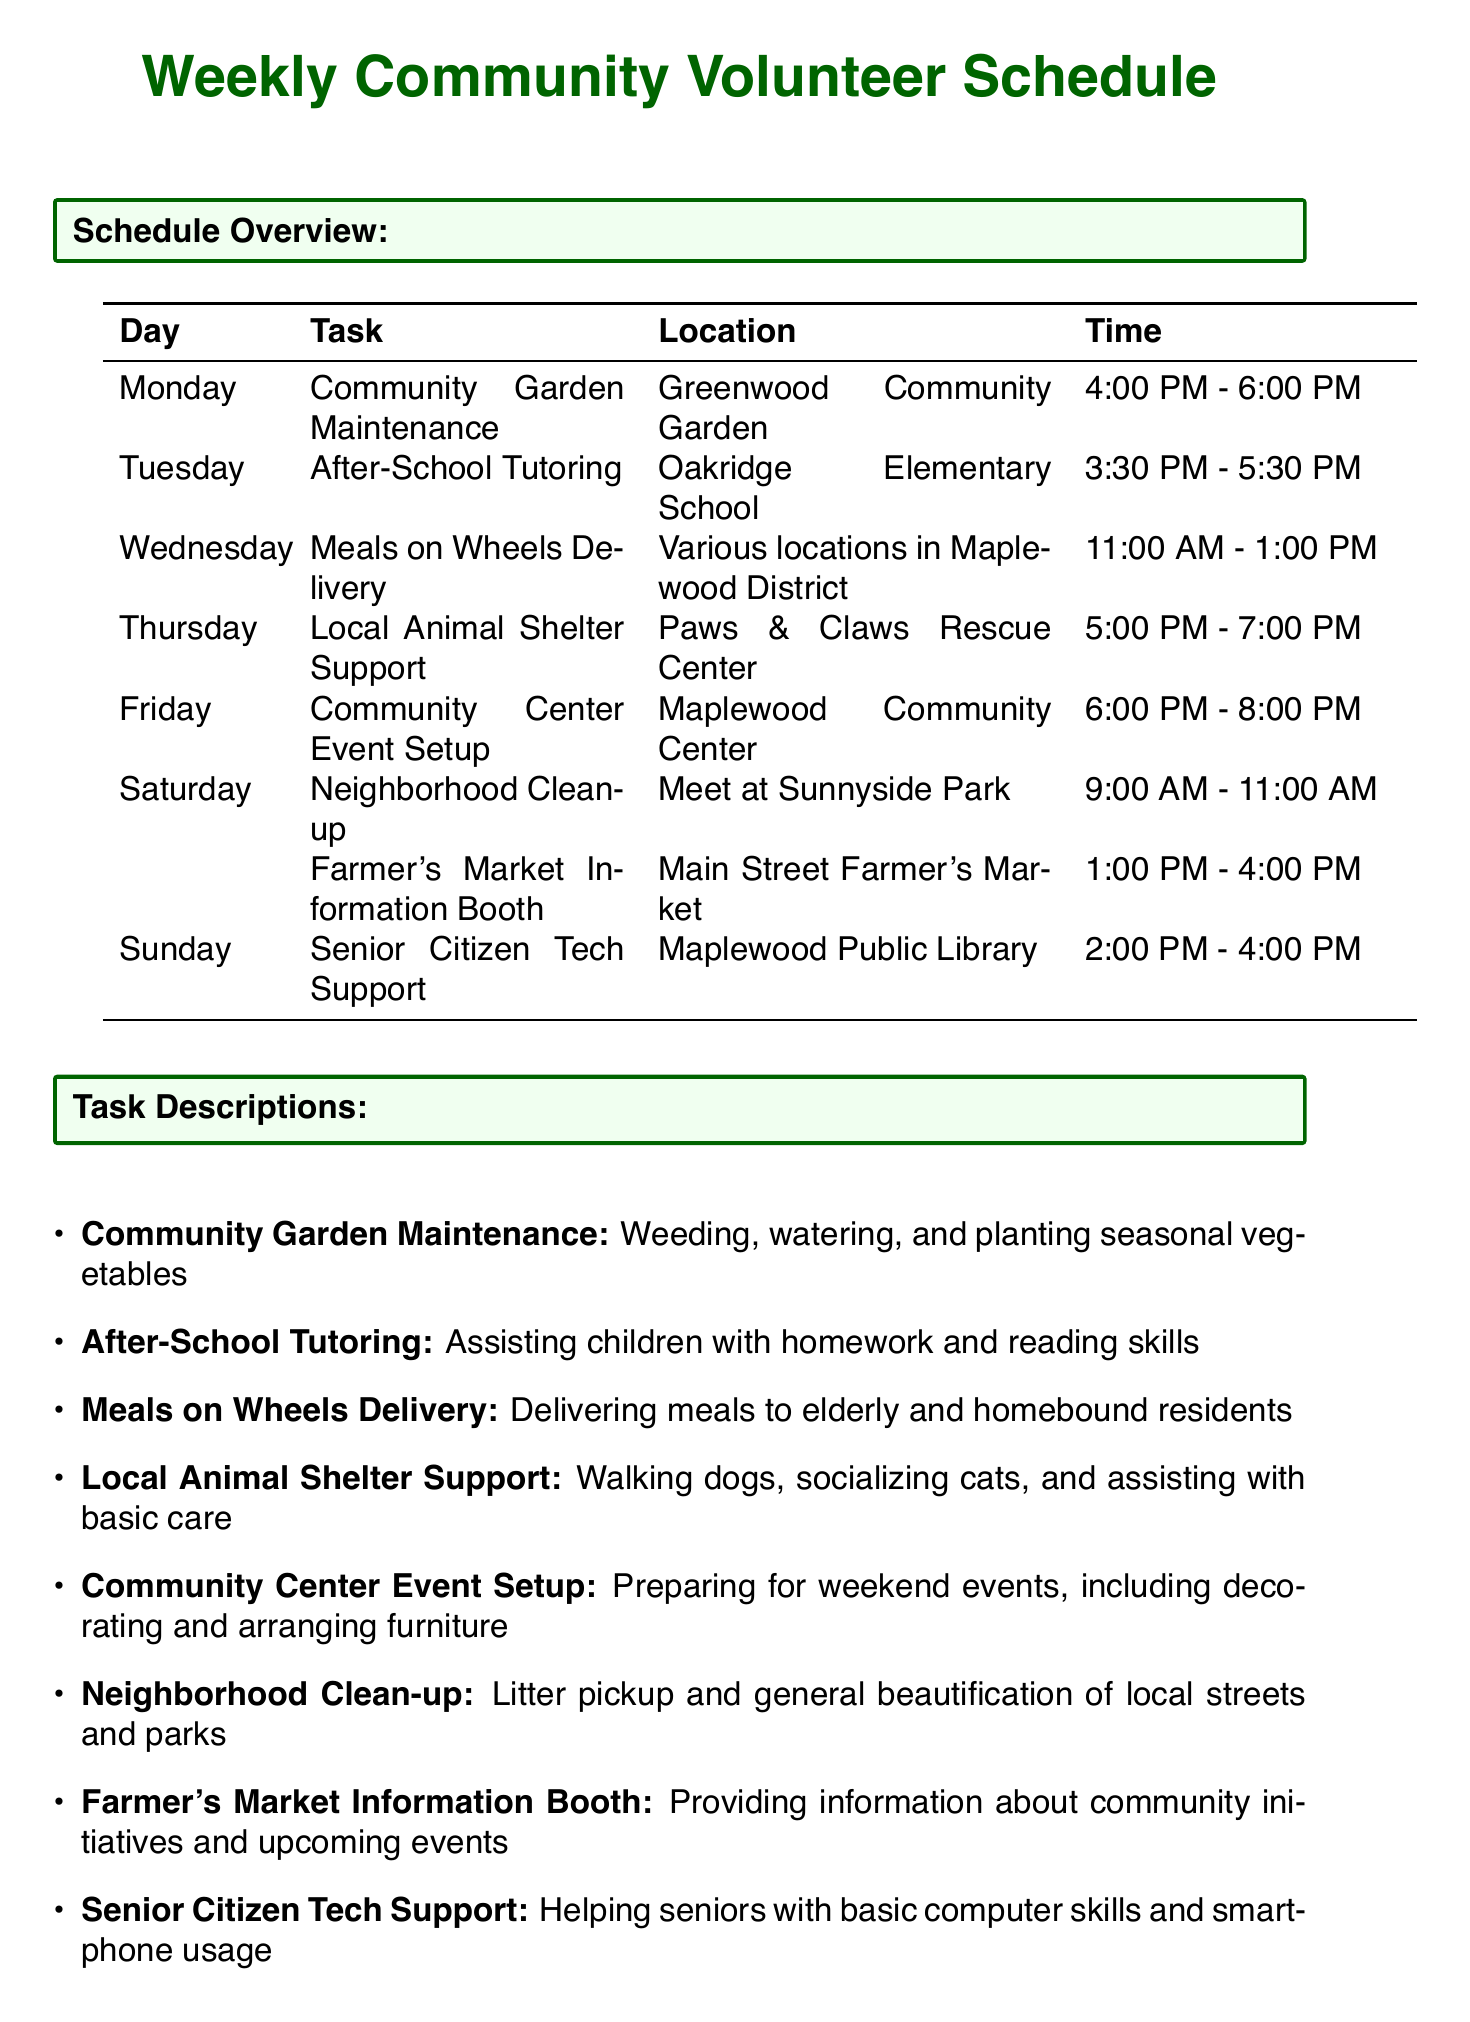What task is scheduled for Monday? The document lists the task for Monday, which is "Community Garden Maintenance."
Answer: Community Garden Maintenance What time does After-School Tutoring start? The schedule specifies the starting time for After-School Tutoring on Tuesday as 3:30 PM.
Answer: 3:30 PM Where will the Neighborhood Clean-up take place? The location for the Neighborhood Clean-up on Saturday is mentioned in the document as "Meet at Sunnyside Park."
Answer: Meet at Sunnyside Park How many tasks are assigned to Saturday? The document lists two tasks assigned for Saturday, which can be counted from the schedule.
Answer: 2 Which coordinator's email is provided for volunteer contact? The document includes email details for both coordinators; one example is Emily Johnson's email.
Answer: emily.johnson@maplewoodemail.com What is the contact number for the emergency contact? The emergency contact number provided in the document is indicated as "555-789-0123."
Answer: 555-789-0123 What activity is planned for Wednesday? The scheduled activity for Wednesday is "Meals on Wheels Delivery."
Answer: Meals on Wheels Delivery What is the expected duration of the Farmer's Market Information Booth? The document states that the Farmer's Market Information Booth is from 1:00 PM to 4:00 PM, totaling three hours.
Answer: 3 hours What note suggests arriving early for shifts? The document contains a note stating to arrive 10 minutes early for each shift.
Answer: 10 minutes early 